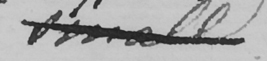What does this handwritten line say? small 